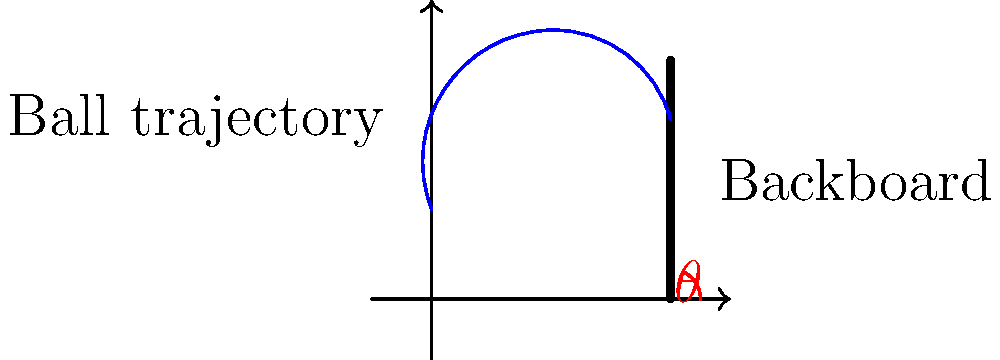As a basketball coach interested in optimizing game performance, you want to determine the ideal angle for the backboard to maximize rebounds. Given that the ball's trajectory follows a parabolic path and hits the backboard at its highest point, what angle $\theta$ should the backboard be tilted from vertical to ensure the ball rebounds as close to horizontal as possible, maximizing the chance of offensive rebounds? To determine the optimal angle for the backboard, we need to consider the principle of reflection:

1. The angle of incidence equals the angle of reflection.

2. At the highest point of the ball's trajectory, its velocity is tangent to the parabola.

3. For the ball to rebound as close to horizontal as possible, we want the angle of reflection to be as close to 90° from the vertical as possible.

4. Let's consider the backboard angle $\theta$ from vertical:
   - The normal to the backboard surface is at angle $\theta$ from horizontal.
   - The incoming ball's trajectory at its highest point is perpendicular to this normal.

5. Therefore, the angle between the incoming ball's trajectory and the vertical is also $\theta$.

6. For the reflected ball to travel horizontally:
   - Angle of incidence = Angle of reflection = $45°$
   - This means the backboard should be tilted at $\theta = 45°$ from vertical.

7. At this angle, the incoming ball at $45°$ from vertical will reflect horizontally, maximizing the chance of offensive rebounds.

This $45°$ angle ensures that the energy of the ball is redirected optimally for offensive rebounding opportunities, aligning with both basketball strategy and the principles of physics.
Answer: $45°$ from vertical 